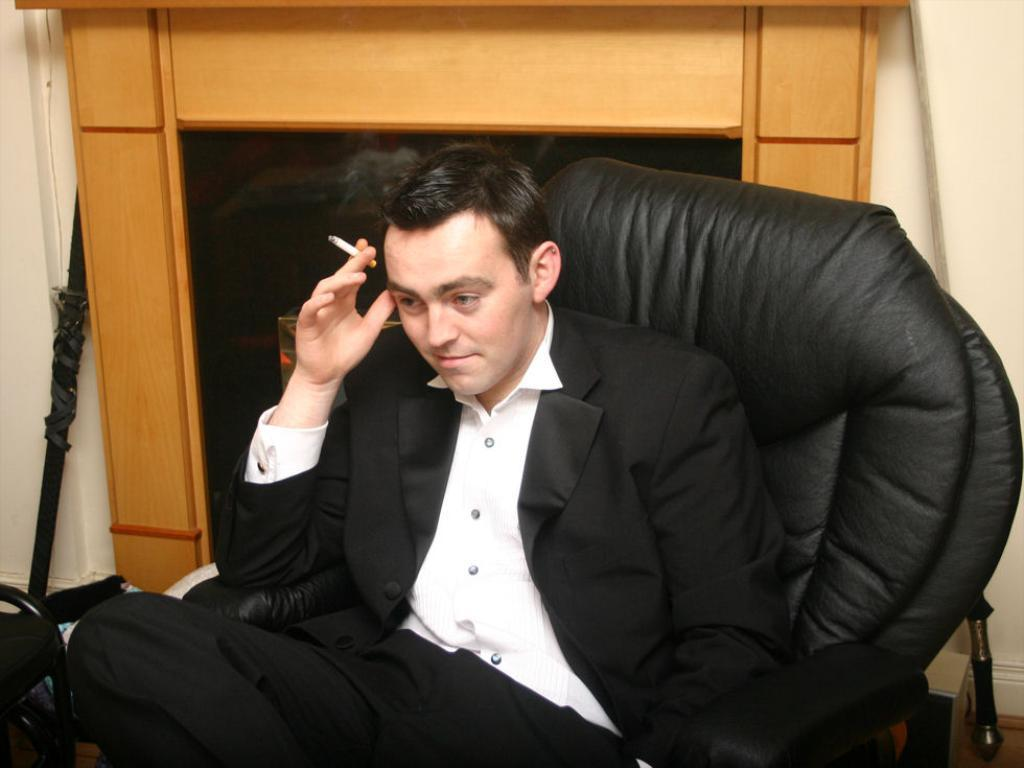Who is present in the image? There is a man in the image. What is the man doing in the image? The man is seated on a chair in the image. What is the man holding in his hand? The man is holding a cigarette in his hand. What type of airplane is visible in the image? There is no airplane present in the image; it only features a man seated on a chair holding a cigarette. 